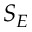<formula> <loc_0><loc_0><loc_500><loc_500>S _ { E }</formula> 